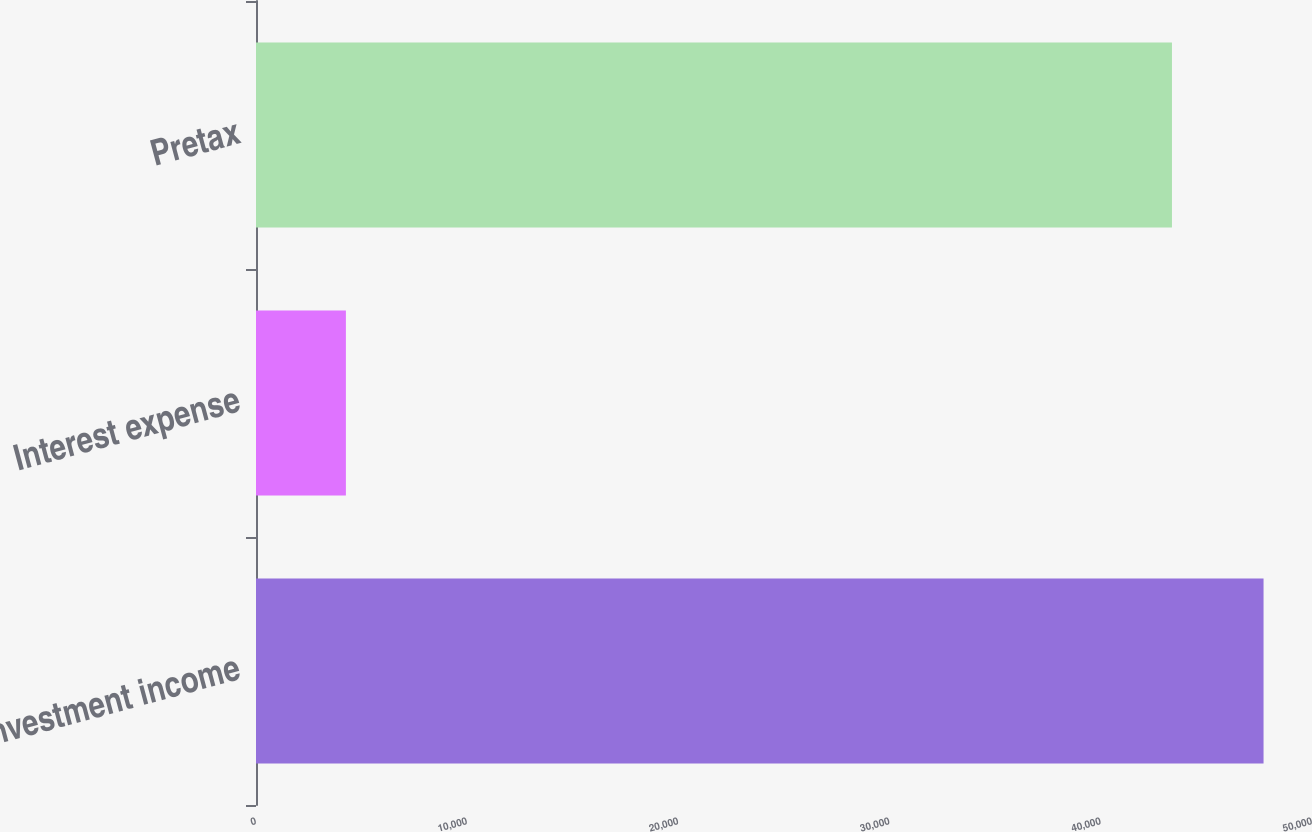Convert chart to OTSL. <chart><loc_0><loc_0><loc_500><loc_500><bar_chart><fcel>Investment income<fcel>Interest expense<fcel>Pretax<nl><fcel>47705.9<fcel>4256<fcel>43369<nl></chart> 